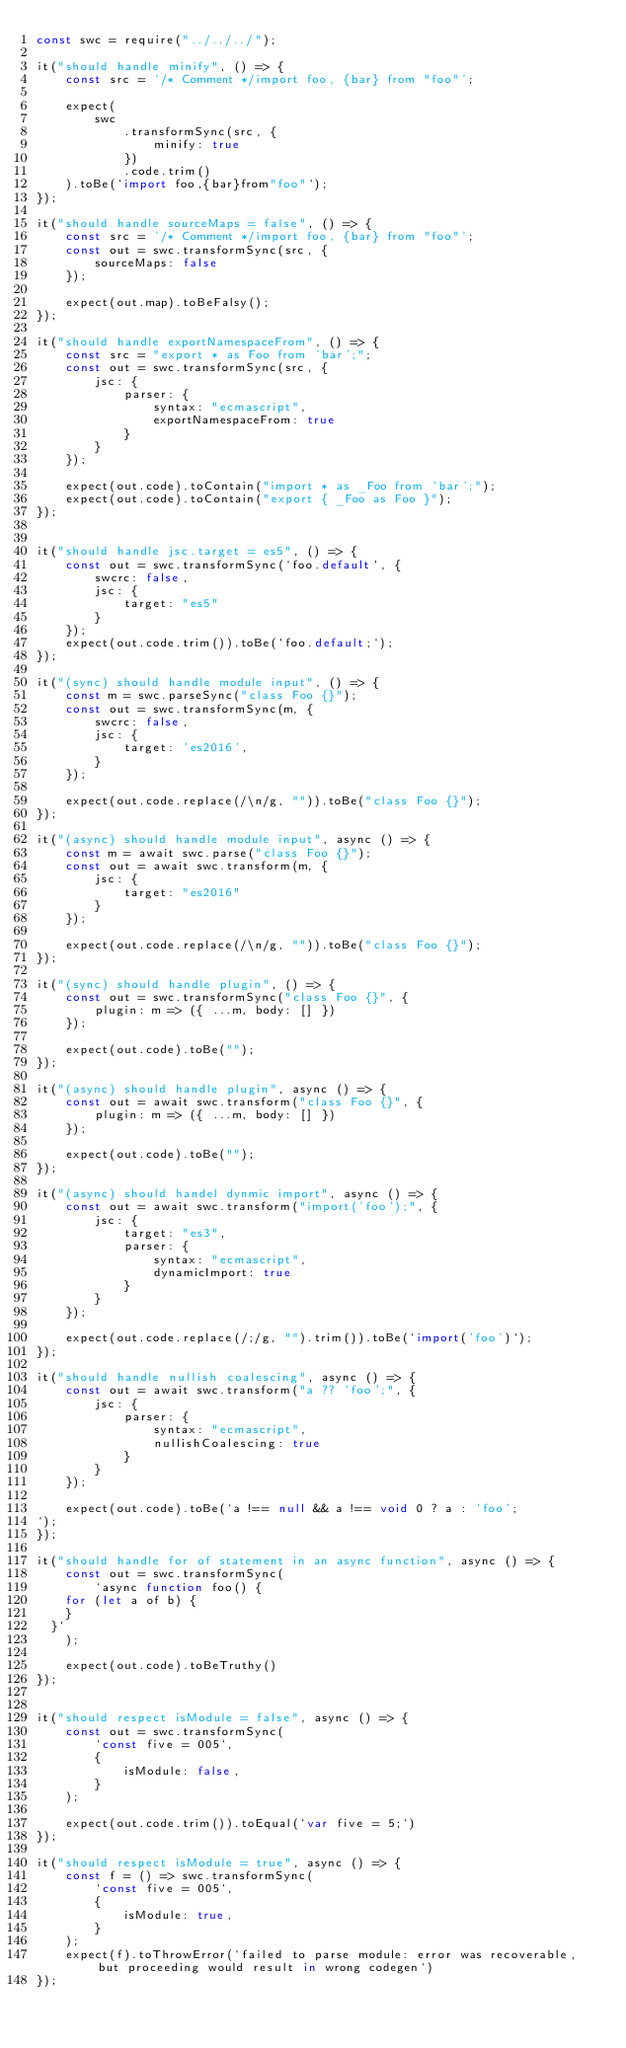<code> <loc_0><loc_0><loc_500><loc_500><_JavaScript_>const swc = require("../../../");

it("should handle minify", () => {
    const src = '/* Comment */import foo, {bar} from "foo"';

    expect(
        swc
            .transformSync(src, {
                minify: true
            })
            .code.trim()
    ).toBe(`import foo,{bar}from"foo"`);
});

it("should handle sourceMaps = false", () => {
    const src = '/* Comment */import foo, {bar} from "foo"';
    const out = swc.transformSync(src, {
        sourceMaps: false
    });

    expect(out.map).toBeFalsy();
});

it("should handle exportNamespaceFrom", () => {
    const src = "export * as Foo from 'bar';";
    const out = swc.transformSync(src, {
        jsc: {
            parser: {
                syntax: "ecmascript",
                exportNamespaceFrom: true
            }
        }
    });

    expect(out.code).toContain("import * as _Foo from 'bar';");
    expect(out.code).toContain("export { _Foo as Foo }");
});


it("should handle jsc.target = es5", () => {
    const out = swc.transformSync(`foo.default`, {
        swcrc: false,
        jsc: {
            target: "es5"
        }
    });
    expect(out.code.trim()).toBe(`foo.default;`);
});

it("(sync) should handle module input", () => {
    const m = swc.parseSync("class Foo {}");
    const out = swc.transformSync(m, {
        swcrc: false,
        jsc: {
            target: 'es2016',
        }
    });

    expect(out.code.replace(/\n/g, "")).toBe("class Foo {}");
});

it("(async) should handle module input", async () => {
    const m = await swc.parse("class Foo {}");
    const out = await swc.transform(m, {
        jsc: {
            target: "es2016"
        }
    });

    expect(out.code.replace(/\n/g, "")).toBe("class Foo {}");
});

it("(sync) should handle plugin", () => {
    const out = swc.transformSync("class Foo {}", {
        plugin: m => ({ ...m, body: [] })
    });

    expect(out.code).toBe("");
});

it("(async) should handle plugin", async () => {
    const out = await swc.transform("class Foo {}", {
        plugin: m => ({ ...m, body: [] })
    });

    expect(out.code).toBe("");
});

it("(async) should handel dynmic import", async () => {
    const out = await swc.transform("import('foo');", {
        jsc: {
            target: "es3",
            parser: {
                syntax: "ecmascript",
                dynamicImport: true
            }
        }
    });

    expect(out.code.replace(/;/g, "").trim()).toBe(`import('foo')`);
});

it("should handle nullish coalescing", async () => {
    const out = await swc.transform("a ?? 'foo';", {
        jsc: {
            parser: {
                syntax: "ecmascript",
                nullishCoalescing: true
            }
        }
    });

    expect(out.code).toBe(`a !== null && a !== void 0 ? a : 'foo';
`);
});

it("should handle for of statement in an async function", async () => {
    const out = swc.transformSync(
        `async function foo() {
    for (let a of b) {
    }
  }`
    );

    expect(out.code).toBeTruthy()
});


it("should respect isModule = false", async () => {
    const out = swc.transformSync(
        `const five = 005`,
        {
            isModule: false,
        }
    );

    expect(out.code.trim()).toEqual(`var five = 5;`)
});

it("should respect isModule = true", async () => {
    const f = () => swc.transformSync(
        `const five = 005`,
        {
            isModule: true,
        }
    );
    expect(f).toThrowError(`failed to parse module: error was recoverable, but proceeding would result in wrong codegen`)
});
</code> 